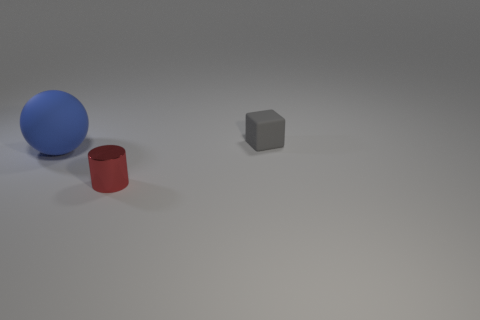Add 1 big cyan spheres. How many objects exist? 4 Subtract all cylinders. How many objects are left? 2 Add 2 small rubber things. How many small rubber things are left? 3 Add 3 metallic cylinders. How many metallic cylinders exist? 4 Subtract 0 green cubes. How many objects are left? 3 Subtract all large blue rubber balls. Subtract all metallic cylinders. How many objects are left? 1 